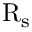<formula> <loc_0><loc_0><loc_500><loc_500>R _ { s }</formula> 